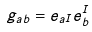<formula> <loc_0><loc_0><loc_500><loc_500>g _ { a b } = e _ { a I } e _ { b } ^ { I }</formula> 